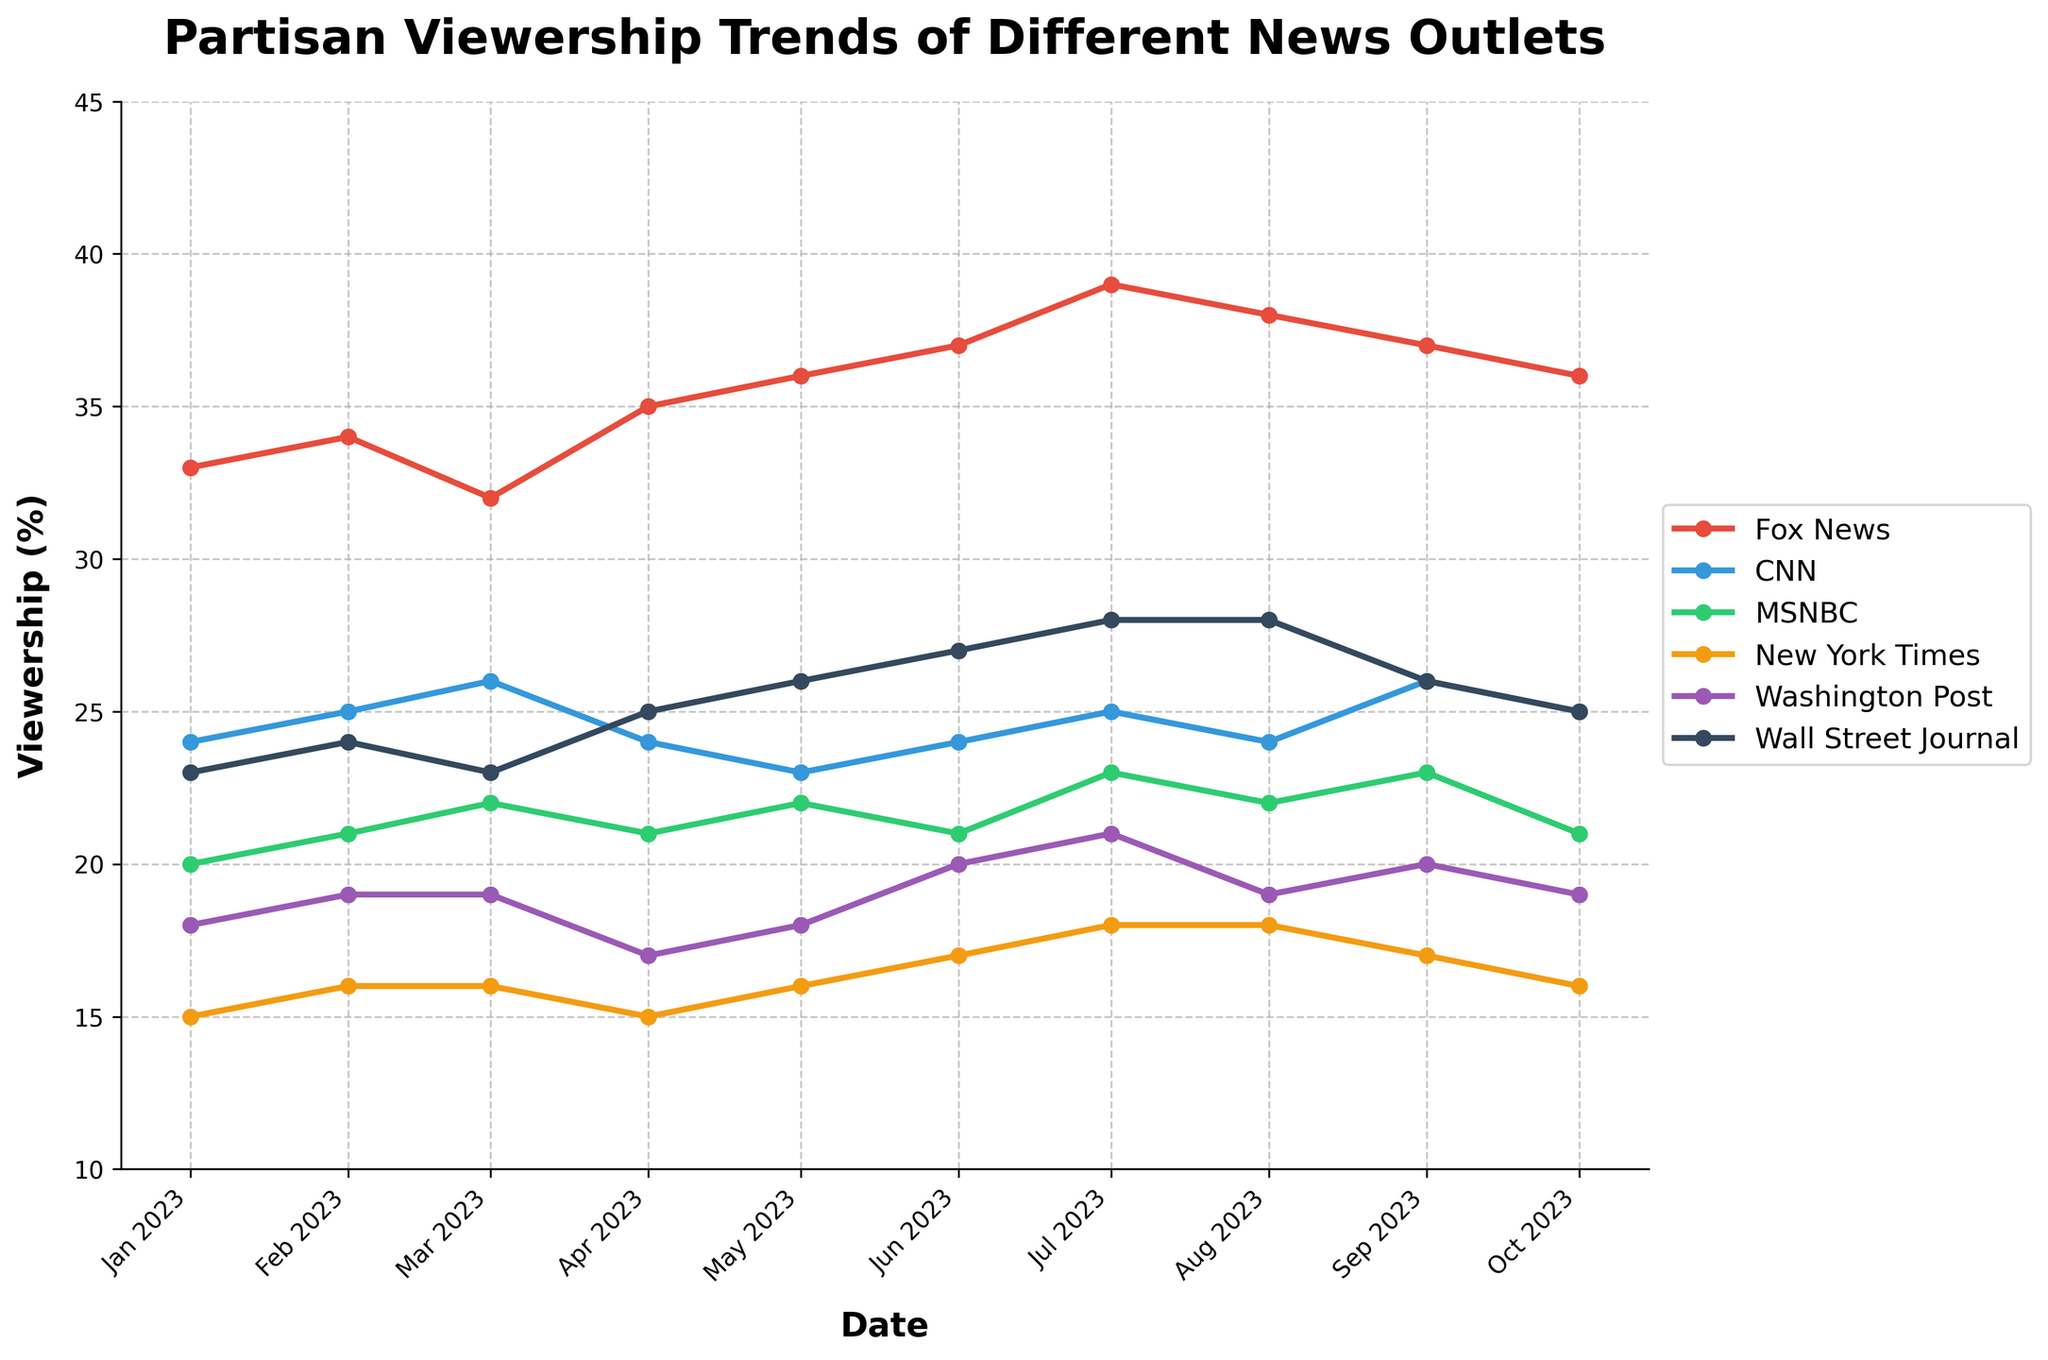What news outlet saw the highest viewership percentage? Look at all the lines on the plot and identify which one consistently has the highest percentages. The line representing Fox News is consistently the highest.
Answer: Fox News How did the viewership percentage of MSNBC change from January 2023 to October 2023? Find the MSNBC line on the plot and note the percentage in January, which is around 20%, and compare it to October, which is around 21%.
Answer: Increased by 1% Which two news outlets have the closest viewership percentages in October 2023? Look at the viewership percentages for all news outlets in October 2023 and find the two that are closest in value, which are MSNBC and CNN both around 21% and 25%, respectively.
Answer: MSNBC and Washington Post What is the average viewership for CNN over the entire period? Calculate the average of the CNN data points provided in the table: (24 + 25 + 26 + 24 + 23 + 24 + 25 + 24 + 26 + 25)/10 = 24.6.
Answer: 24.6% Which news outlet had the most fluctuation in viewership percentage? Determine which line on the plot shows the most variation throughout the months. The Fox News line shows notable fluctuations with changes between 32% and 39%.
Answer: Fox News By how much did the viewership percentage of the New York Times increase from January 2023 to July 2023? Note the percentage for the New York Times in January 2023 (15%) and compare it to July 2023 (18%), the difference is 18% - 15% = 3%.
Answer: 3% Which month saw an equal viewership percentage for MSNBC and New York Times? Check all data points and plot lines to find where the MSNBC and New York Times values are the same. Both have 22% in March 2023.
Answer: March 2023 When did Fox News see its peak viewership and what was the percentage? Look at the plot and note when the Fox News line is highest, which is July 2023 at around 39%.
Answer: July 2023, 39% How many times did CNN's viewership percentage decrease month-over-month? Count the instances on the plot where CNN's percentage goes down from one month to the next. Decreases occur in May, August, and October, a total of 3 times.
Answer: 3 times What was the trend for the Wall Street Journal from June 2023 to October 2023? Look at the plot and trace the Wall Street Journal line from June to October. The trend shows a general decrease from 27% to 25%.
Answer: Decreasing trend 